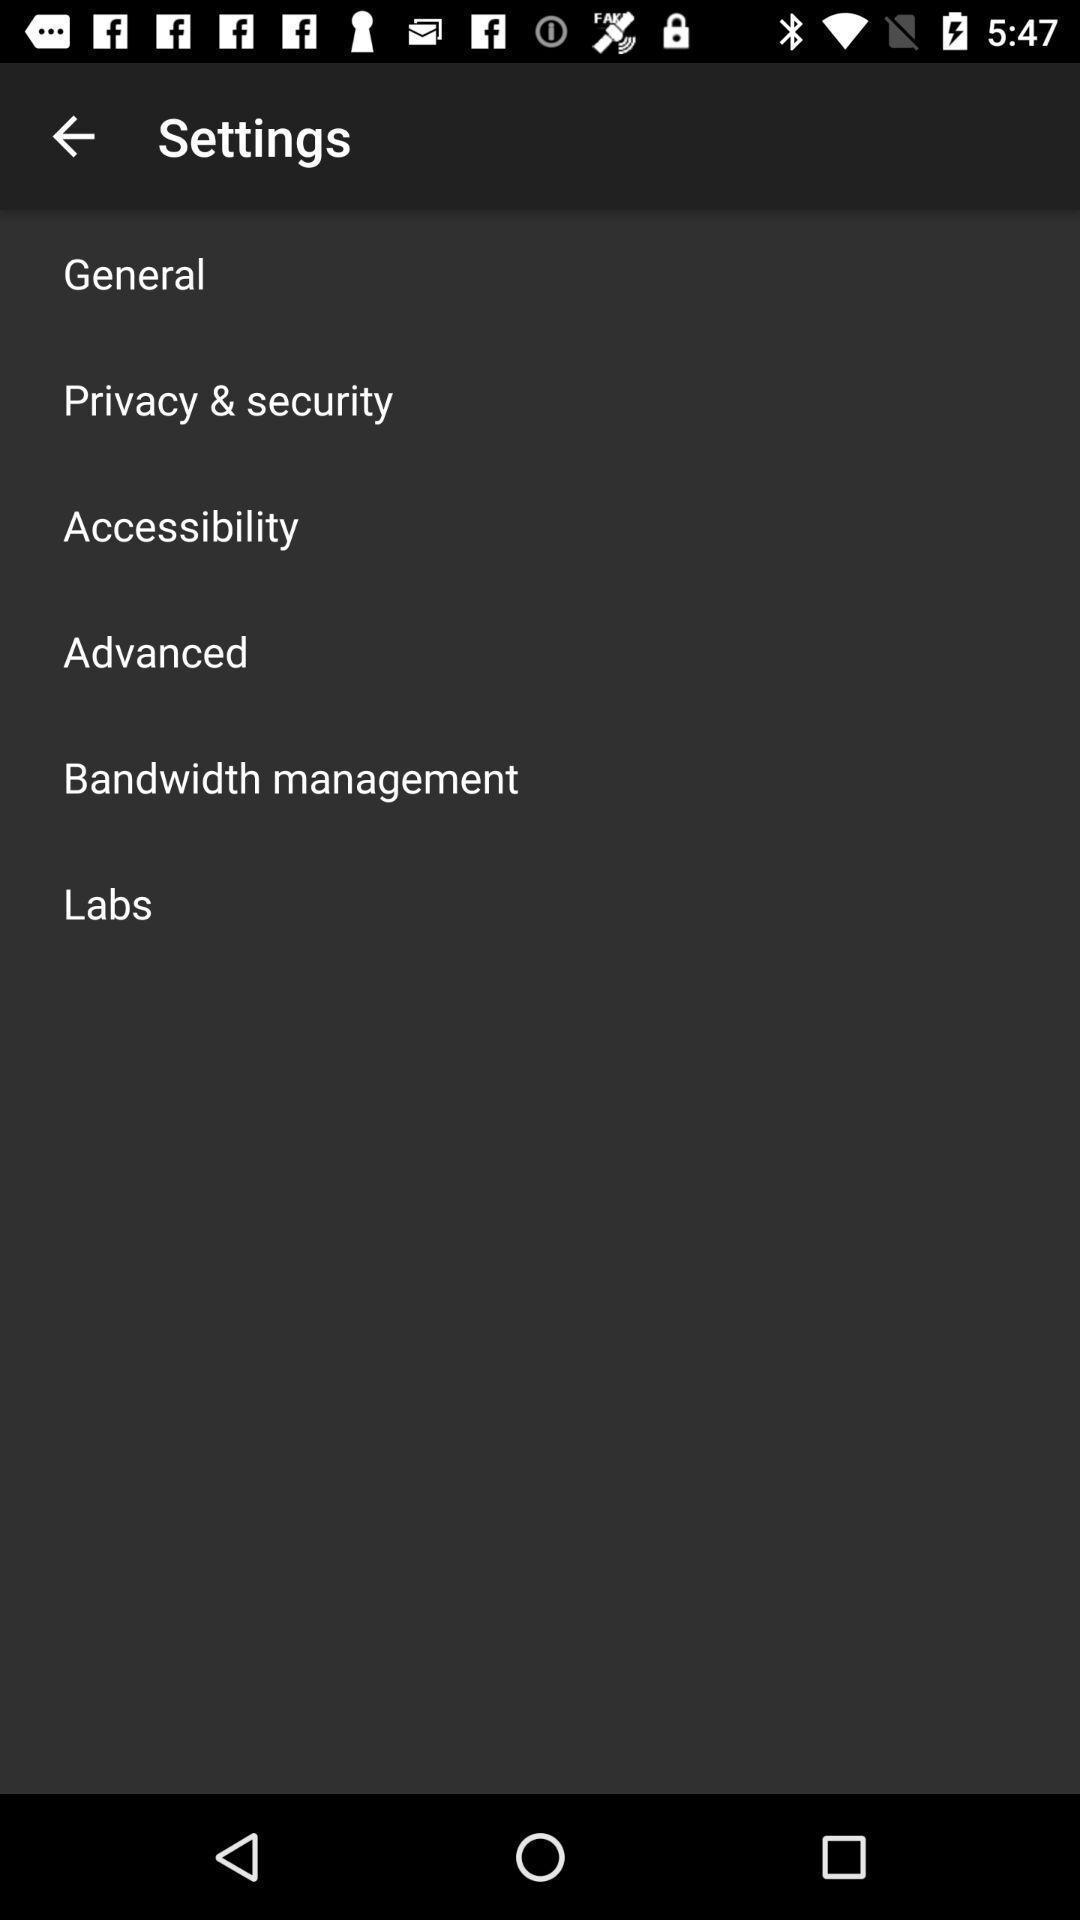Tell me what you see in this picture. Screen displaying the settings page. 